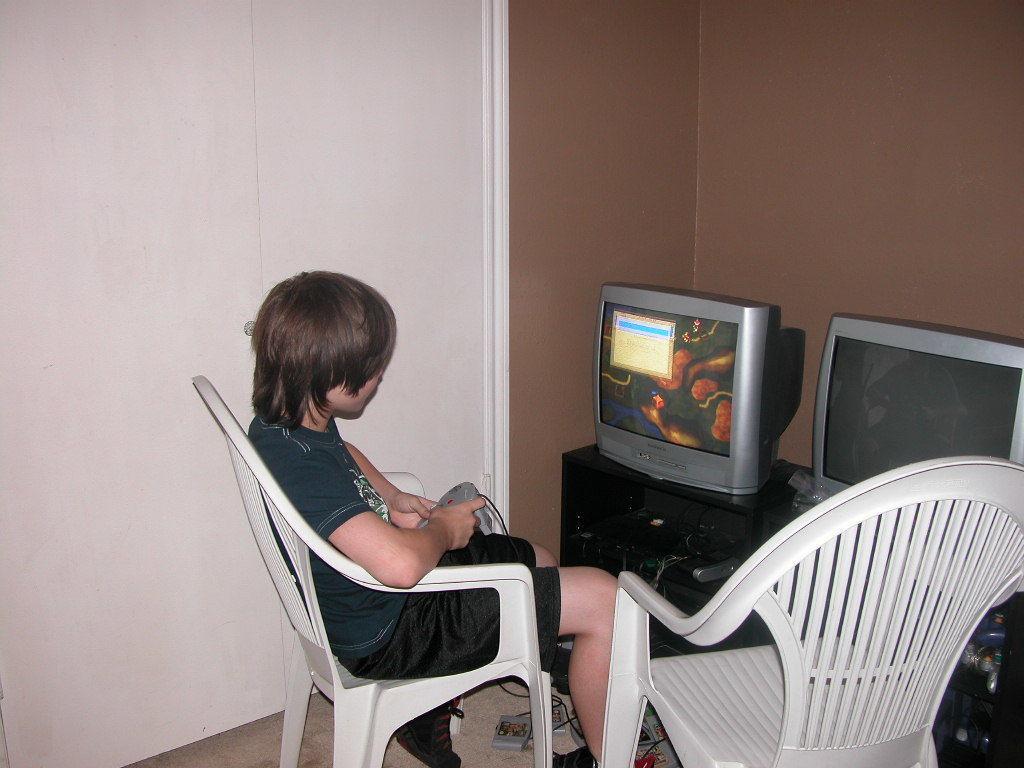Could you give a brief overview of what you see in this image? In the image we can see a child wearing clothes and holding a device in hands, and the child is sitting on the chair. Here we can see two chairs and two electronic devices. Here we can see the cable wires, floor and the wall. 